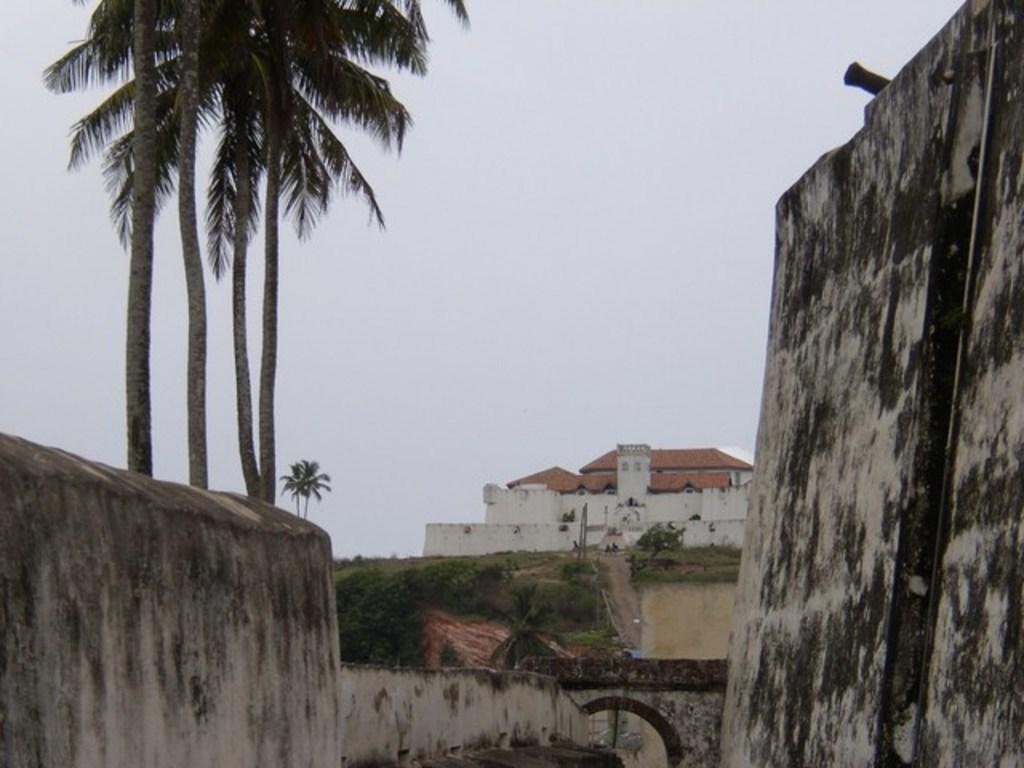What type of natural elements can be seen in the image? There are trees in the image. What architectural features are present on the sides of the image? There are walls on either side of the image. What type of structure can be seen in the background of the image? There is a building in the background of the image. What part of the natural environment is visible in the background of the image? The sky is visible in the background of the image. What is the income of the nut that is visible in the image? There is no nut present in the image, so it is not possible to determine its income. 